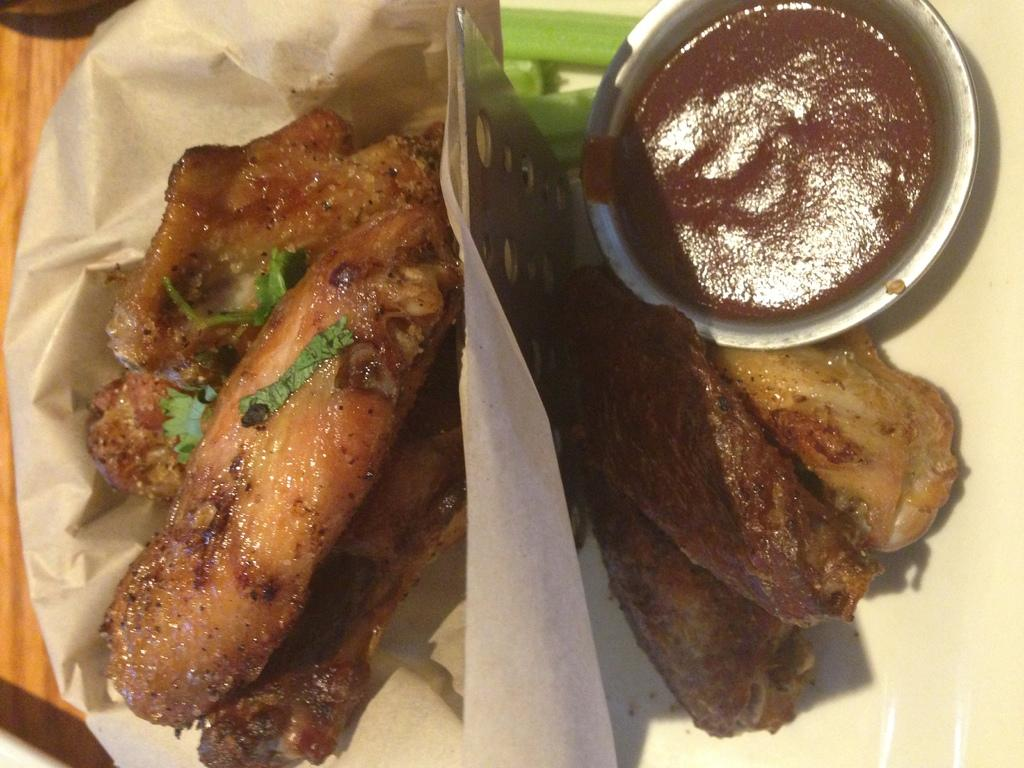What type of objects can be seen in the image? There are food items, a bowl, and a plate in the image. Where are the bowl and plate located in the image? The bowl and plate are on the right side of the image. What else is present in the image besides the food items, bowl, and plate? There is a paper in the image. Where is the paper located in the image? The paper is on the left side of the image. How many holes can be seen in the cup in the image? There is no cup present in the image, so there are no holes to count. 